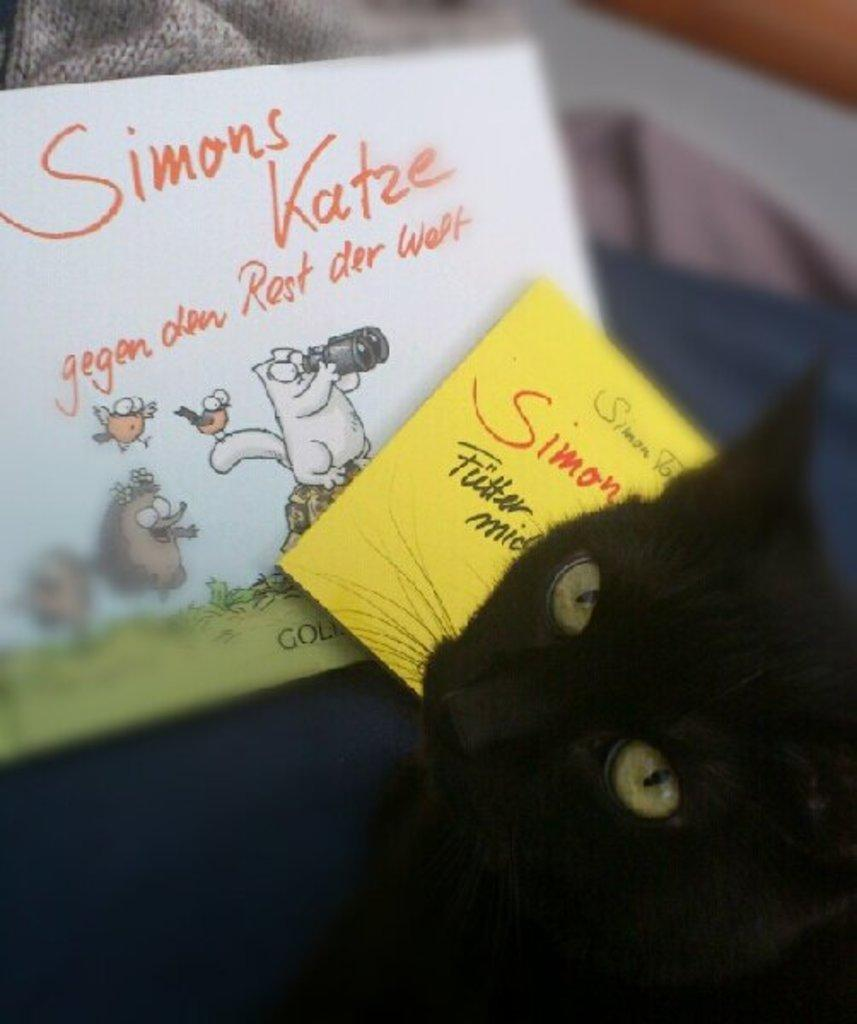What type of animal is at the bottom of the image? There is a black cat at the bottom of the image. What can be seen in the middle of the image? Two posts are present in the middle of the image. What type of shop can be seen in the image? There is no shop present in the image; it only features a black cat and two posts. How does the disgust factor play a role in the image? The image does not convey any sense of disgust, as it only contains a black cat and two posts. 